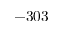Convert formula to latex. <formula><loc_0><loc_0><loc_500><loc_500>- 3 0 3</formula> 